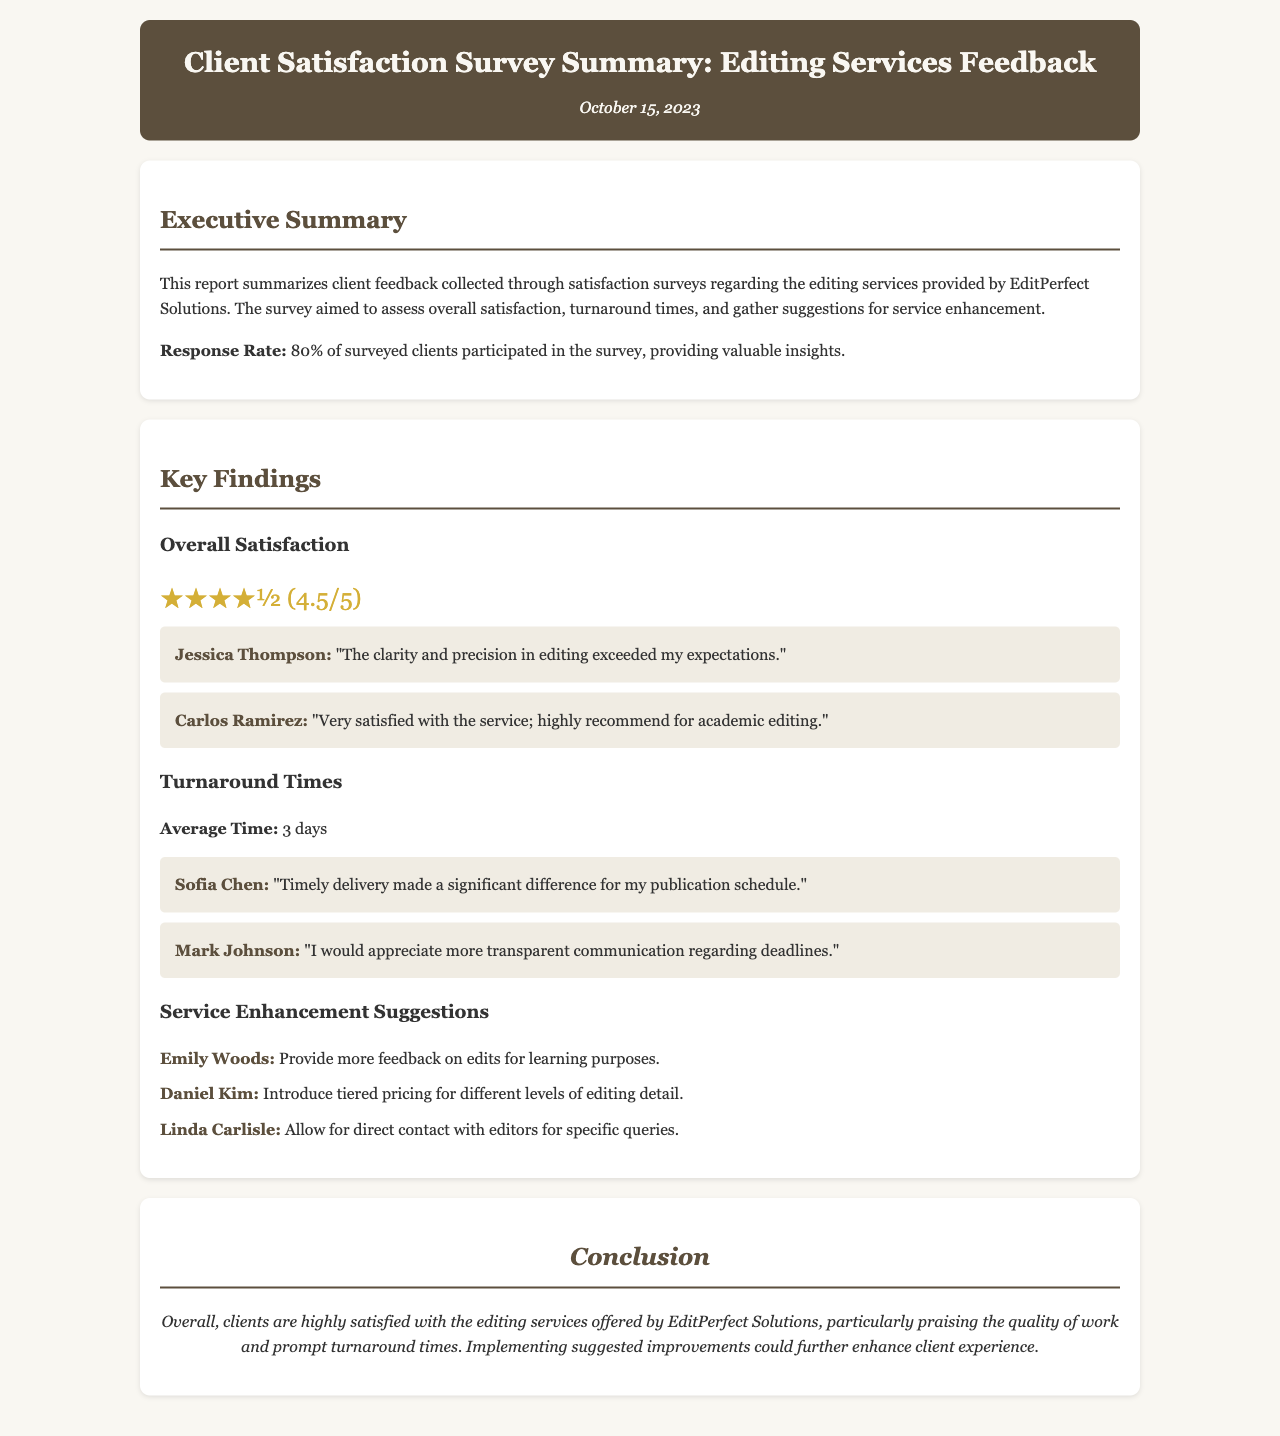What is the overall satisfaction rating? The overall satisfaction rating is mentioned as ★★★★½ (4.5/5), indicating high client satisfaction.
Answer: ★★★★½ (4.5/5) What is the average turnaround time for editing services? The average turnaround time is provided in the document, highlighting the typical duration clients experience.
Answer: 3 days Who provided the feedback stating that delivery made a significant difference for their publication schedule? Sofia Chen's feedback indicates her appreciation for timely delivery impacting her publication schedule.
Answer: Sofia Chen What suggestion did Emily Woods make for service enhancement? The document lists various suggestions; Emily Woods specifically recommended providing more feedback on edits for learning purposes.
Answer: Provide more feedback on edits for learning purposes What percentage of clients participated in the survey? The response rate is explicitly stated, showing the proportion of surveyed clients who responded to the feedback request.
Answer: 80% 